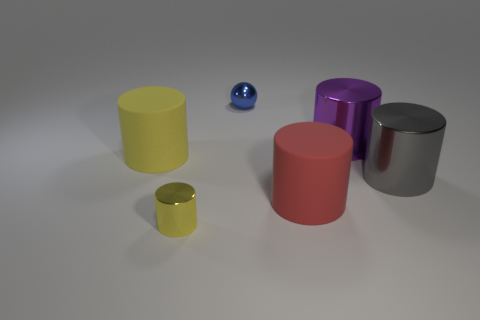Subtract all tiny metal cylinders. How many cylinders are left? 4 Add 3 big red matte objects. How many objects exist? 9 Subtract all yellow cylinders. How many cylinders are left? 3 Subtract 1 spheres. How many spheres are left? 0 Subtract all gray cubes. How many yellow cylinders are left? 2 Add 5 gray shiny cylinders. How many gray shiny cylinders are left? 6 Add 1 small brown cubes. How many small brown cubes exist? 1 Subtract 0 purple blocks. How many objects are left? 6 Subtract all cylinders. How many objects are left? 1 Subtract all gray balls. Subtract all purple cylinders. How many balls are left? 1 